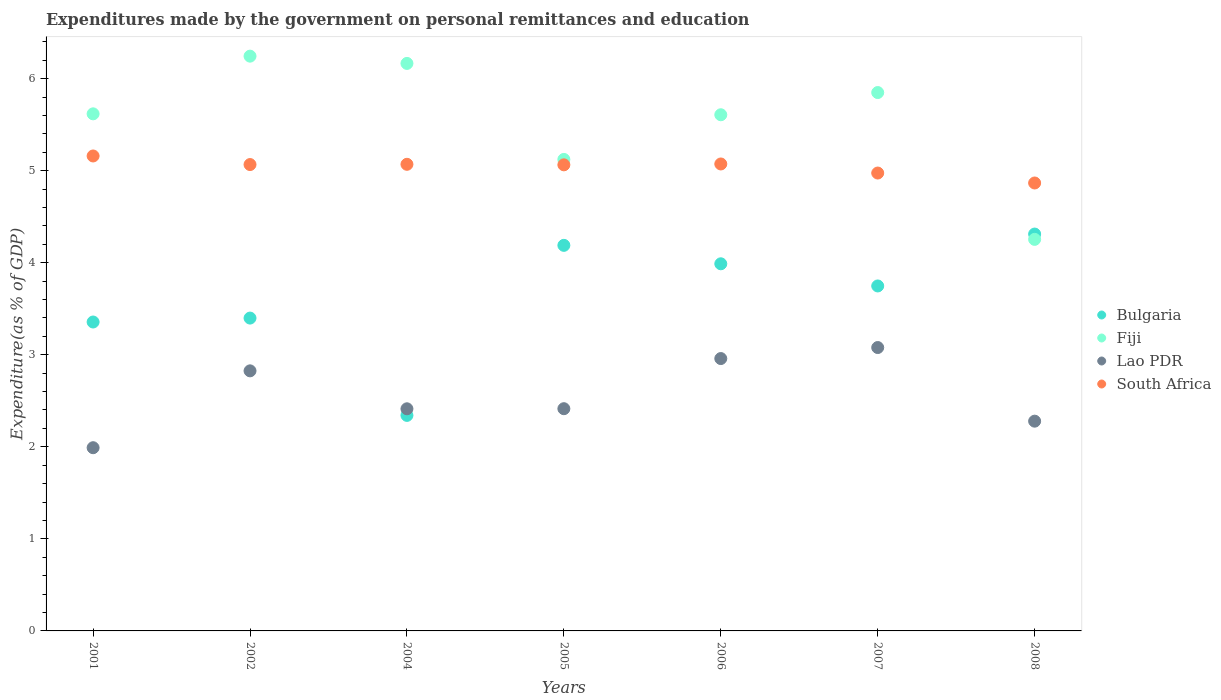Is the number of dotlines equal to the number of legend labels?
Your answer should be very brief. Yes. What is the expenditures made by the government on personal remittances and education in Fiji in 2006?
Provide a short and direct response. 5.61. Across all years, what is the maximum expenditures made by the government on personal remittances and education in Lao PDR?
Your response must be concise. 3.08. Across all years, what is the minimum expenditures made by the government on personal remittances and education in Lao PDR?
Your answer should be very brief. 1.99. In which year was the expenditures made by the government on personal remittances and education in Lao PDR minimum?
Offer a very short reply. 2001. What is the total expenditures made by the government on personal remittances and education in Fiji in the graph?
Offer a terse response. 38.86. What is the difference between the expenditures made by the government on personal remittances and education in Bulgaria in 2004 and that in 2006?
Your response must be concise. -1.65. What is the difference between the expenditures made by the government on personal remittances and education in Bulgaria in 2004 and the expenditures made by the government on personal remittances and education in Lao PDR in 2005?
Give a very brief answer. -0.07. What is the average expenditures made by the government on personal remittances and education in Bulgaria per year?
Give a very brief answer. 3.62. In the year 2007, what is the difference between the expenditures made by the government on personal remittances and education in Lao PDR and expenditures made by the government on personal remittances and education in South Africa?
Your response must be concise. -1.9. In how many years, is the expenditures made by the government on personal remittances and education in Lao PDR greater than 0.4 %?
Make the answer very short. 7. What is the ratio of the expenditures made by the government on personal remittances and education in Bulgaria in 2001 to that in 2006?
Ensure brevity in your answer.  0.84. Is the expenditures made by the government on personal remittances and education in Fiji in 2002 less than that in 2008?
Provide a succinct answer. No. What is the difference between the highest and the second highest expenditures made by the government on personal remittances and education in Bulgaria?
Your response must be concise. 0.12. What is the difference between the highest and the lowest expenditures made by the government on personal remittances and education in South Africa?
Provide a succinct answer. 0.29. In how many years, is the expenditures made by the government on personal remittances and education in Fiji greater than the average expenditures made by the government on personal remittances and education in Fiji taken over all years?
Keep it short and to the point. 5. Is it the case that in every year, the sum of the expenditures made by the government on personal remittances and education in Bulgaria and expenditures made by the government on personal remittances and education in Fiji  is greater than the expenditures made by the government on personal remittances and education in Lao PDR?
Ensure brevity in your answer.  Yes. Is the expenditures made by the government on personal remittances and education in Fiji strictly greater than the expenditures made by the government on personal remittances and education in Lao PDR over the years?
Your answer should be very brief. Yes. Is the expenditures made by the government on personal remittances and education in Bulgaria strictly less than the expenditures made by the government on personal remittances and education in South Africa over the years?
Ensure brevity in your answer.  Yes. How many dotlines are there?
Give a very brief answer. 4. How many years are there in the graph?
Keep it short and to the point. 7. Are the values on the major ticks of Y-axis written in scientific E-notation?
Give a very brief answer. No. Does the graph contain any zero values?
Make the answer very short. No. Where does the legend appear in the graph?
Your answer should be compact. Center right. How many legend labels are there?
Keep it short and to the point. 4. How are the legend labels stacked?
Your answer should be compact. Vertical. What is the title of the graph?
Give a very brief answer. Expenditures made by the government on personal remittances and education. Does "Benin" appear as one of the legend labels in the graph?
Give a very brief answer. No. What is the label or title of the X-axis?
Keep it short and to the point. Years. What is the label or title of the Y-axis?
Your answer should be very brief. Expenditure(as % of GDP). What is the Expenditure(as % of GDP) of Bulgaria in 2001?
Keep it short and to the point. 3.36. What is the Expenditure(as % of GDP) in Fiji in 2001?
Your answer should be very brief. 5.62. What is the Expenditure(as % of GDP) of Lao PDR in 2001?
Ensure brevity in your answer.  1.99. What is the Expenditure(as % of GDP) of South Africa in 2001?
Your response must be concise. 5.16. What is the Expenditure(as % of GDP) of Bulgaria in 2002?
Keep it short and to the point. 3.4. What is the Expenditure(as % of GDP) in Fiji in 2002?
Make the answer very short. 6.24. What is the Expenditure(as % of GDP) of Lao PDR in 2002?
Make the answer very short. 2.83. What is the Expenditure(as % of GDP) in South Africa in 2002?
Your answer should be very brief. 5.07. What is the Expenditure(as % of GDP) in Bulgaria in 2004?
Provide a short and direct response. 2.34. What is the Expenditure(as % of GDP) of Fiji in 2004?
Your answer should be very brief. 6.16. What is the Expenditure(as % of GDP) of Lao PDR in 2004?
Provide a succinct answer. 2.41. What is the Expenditure(as % of GDP) in South Africa in 2004?
Ensure brevity in your answer.  5.07. What is the Expenditure(as % of GDP) in Bulgaria in 2005?
Give a very brief answer. 4.19. What is the Expenditure(as % of GDP) in Fiji in 2005?
Your response must be concise. 5.12. What is the Expenditure(as % of GDP) in Lao PDR in 2005?
Your answer should be compact. 2.41. What is the Expenditure(as % of GDP) in South Africa in 2005?
Give a very brief answer. 5.06. What is the Expenditure(as % of GDP) in Bulgaria in 2006?
Make the answer very short. 3.99. What is the Expenditure(as % of GDP) in Fiji in 2006?
Your response must be concise. 5.61. What is the Expenditure(as % of GDP) in Lao PDR in 2006?
Provide a short and direct response. 2.96. What is the Expenditure(as % of GDP) of South Africa in 2006?
Your answer should be compact. 5.07. What is the Expenditure(as % of GDP) of Bulgaria in 2007?
Provide a short and direct response. 3.75. What is the Expenditure(as % of GDP) of Fiji in 2007?
Your answer should be compact. 5.85. What is the Expenditure(as % of GDP) of Lao PDR in 2007?
Keep it short and to the point. 3.08. What is the Expenditure(as % of GDP) in South Africa in 2007?
Your answer should be compact. 4.97. What is the Expenditure(as % of GDP) in Bulgaria in 2008?
Offer a terse response. 4.31. What is the Expenditure(as % of GDP) in Fiji in 2008?
Your answer should be very brief. 4.25. What is the Expenditure(as % of GDP) of Lao PDR in 2008?
Provide a succinct answer. 2.28. What is the Expenditure(as % of GDP) of South Africa in 2008?
Your answer should be very brief. 4.87. Across all years, what is the maximum Expenditure(as % of GDP) of Bulgaria?
Make the answer very short. 4.31. Across all years, what is the maximum Expenditure(as % of GDP) in Fiji?
Give a very brief answer. 6.24. Across all years, what is the maximum Expenditure(as % of GDP) in Lao PDR?
Offer a very short reply. 3.08. Across all years, what is the maximum Expenditure(as % of GDP) in South Africa?
Your response must be concise. 5.16. Across all years, what is the minimum Expenditure(as % of GDP) of Bulgaria?
Provide a succinct answer. 2.34. Across all years, what is the minimum Expenditure(as % of GDP) in Fiji?
Provide a short and direct response. 4.25. Across all years, what is the minimum Expenditure(as % of GDP) of Lao PDR?
Ensure brevity in your answer.  1.99. Across all years, what is the minimum Expenditure(as % of GDP) of South Africa?
Provide a succinct answer. 4.87. What is the total Expenditure(as % of GDP) of Bulgaria in the graph?
Make the answer very short. 25.33. What is the total Expenditure(as % of GDP) in Fiji in the graph?
Keep it short and to the point. 38.86. What is the total Expenditure(as % of GDP) of Lao PDR in the graph?
Give a very brief answer. 17.96. What is the total Expenditure(as % of GDP) in South Africa in the graph?
Your answer should be very brief. 35.27. What is the difference between the Expenditure(as % of GDP) of Bulgaria in 2001 and that in 2002?
Give a very brief answer. -0.04. What is the difference between the Expenditure(as % of GDP) in Fiji in 2001 and that in 2002?
Offer a terse response. -0.63. What is the difference between the Expenditure(as % of GDP) of Lao PDR in 2001 and that in 2002?
Offer a terse response. -0.83. What is the difference between the Expenditure(as % of GDP) of South Africa in 2001 and that in 2002?
Provide a succinct answer. 0.09. What is the difference between the Expenditure(as % of GDP) in Bulgaria in 2001 and that in 2004?
Make the answer very short. 1.01. What is the difference between the Expenditure(as % of GDP) in Fiji in 2001 and that in 2004?
Offer a very short reply. -0.55. What is the difference between the Expenditure(as % of GDP) in Lao PDR in 2001 and that in 2004?
Your answer should be very brief. -0.42. What is the difference between the Expenditure(as % of GDP) in South Africa in 2001 and that in 2004?
Give a very brief answer. 0.09. What is the difference between the Expenditure(as % of GDP) in Bulgaria in 2001 and that in 2005?
Give a very brief answer. -0.83. What is the difference between the Expenditure(as % of GDP) of Fiji in 2001 and that in 2005?
Ensure brevity in your answer.  0.5. What is the difference between the Expenditure(as % of GDP) of Lao PDR in 2001 and that in 2005?
Make the answer very short. -0.42. What is the difference between the Expenditure(as % of GDP) of South Africa in 2001 and that in 2005?
Your response must be concise. 0.1. What is the difference between the Expenditure(as % of GDP) of Bulgaria in 2001 and that in 2006?
Offer a very short reply. -0.63. What is the difference between the Expenditure(as % of GDP) in Lao PDR in 2001 and that in 2006?
Provide a short and direct response. -0.97. What is the difference between the Expenditure(as % of GDP) in South Africa in 2001 and that in 2006?
Offer a very short reply. 0.09. What is the difference between the Expenditure(as % of GDP) of Bulgaria in 2001 and that in 2007?
Make the answer very short. -0.39. What is the difference between the Expenditure(as % of GDP) in Fiji in 2001 and that in 2007?
Your answer should be compact. -0.23. What is the difference between the Expenditure(as % of GDP) in Lao PDR in 2001 and that in 2007?
Provide a succinct answer. -1.09. What is the difference between the Expenditure(as % of GDP) of South Africa in 2001 and that in 2007?
Make the answer very short. 0.19. What is the difference between the Expenditure(as % of GDP) in Bulgaria in 2001 and that in 2008?
Your answer should be very brief. -0.96. What is the difference between the Expenditure(as % of GDP) in Fiji in 2001 and that in 2008?
Offer a very short reply. 1.36. What is the difference between the Expenditure(as % of GDP) in Lao PDR in 2001 and that in 2008?
Offer a terse response. -0.29. What is the difference between the Expenditure(as % of GDP) in South Africa in 2001 and that in 2008?
Your answer should be compact. 0.29. What is the difference between the Expenditure(as % of GDP) in Bulgaria in 2002 and that in 2004?
Ensure brevity in your answer.  1.06. What is the difference between the Expenditure(as % of GDP) of Fiji in 2002 and that in 2004?
Give a very brief answer. 0.08. What is the difference between the Expenditure(as % of GDP) of Lao PDR in 2002 and that in 2004?
Your answer should be compact. 0.41. What is the difference between the Expenditure(as % of GDP) of South Africa in 2002 and that in 2004?
Your answer should be compact. -0. What is the difference between the Expenditure(as % of GDP) in Bulgaria in 2002 and that in 2005?
Offer a very short reply. -0.79. What is the difference between the Expenditure(as % of GDP) in Fiji in 2002 and that in 2005?
Give a very brief answer. 1.12. What is the difference between the Expenditure(as % of GDP) of Lao PDR in 2002 and that in 2005?
Keep it short and to the point. 0.41. What is the difference between the Expenditure(as % of GDP) in South Africa in 2002 and that in 2005?
Ensure brevity in your answer.  0. What is the difference between the Expenditure(as % of GDP) of Bulgaria in 2002 and that in 2006?
Make the answer very short. -0.59. What is the difference between the Expenditure(as % of GDP) of Fiji in 2002 and that in 2006?
Your answer should be very brief. 0.64. What is the difference between the Expenditure(as % of GDP) of Lao PDR in 2002 and that in 2006?
Ensure brevity in your answer.  -0.13. What is the difference between the Expenditure(as % of GDP) in South Africa in 2002 and that in 2006?
Give a very brief answer. -0.01. What is the difference between the Expenditure(as % of GDP) in Bulgaria in 2002 and that in 2007?
Your answer should be compact. -0.35. What is the difference between the Expenditure(as % of GDP) in Fiji in 2002 and that in 2007?
Ensure brevity in your answer.  0.4. What is the difference between the Expenditure(as % of GDP) in Lao PDR in 2002 and that in 2007?
Your response must be concise. -0.25. What is the difference between the Expenditure(as % of GDP) in South Africa in 2002 and that in 2007?
Provide a succinct answer. 0.09. What is the difference between the Expenditure(as % of GDP) of Bulgaria in 2002 and that in 2008?
Your answer should be compact. -0.91. What is the difference between the Expenditure(as % of GDP) in Fiji in 2002 and that in 2008?
Provide a succinct answer. 1.99. What is the difference between the Expenditure(as % of GDP) of Lao PDR in 2002 and that in 2008?
Provide a short and direct response. 0.55. What is the difference between the Expenditure(as % of GDP) of South Africa in 2002 and that in 2008?
Your answer should be compact. 0.2. What is the difference between the Expenditure(as % of GDP) in Bulgaria in 2004 and that in 2005?
Offer a very short reply. -1.85. What is the difference between the Expenditure(as % of GDP) in Fiji in 2004 and that in 2005?
Make the answer very short. 1.04. What is the difference between the Expenditure(as % of GDP) of Lao PDR in 2004 and that in 2005?
Offer a very short reply. -0. What is the difference between the Expenditure(as % of GDP) of South Africa in 2004 and that in 2005?
Your answer should be compact. 0.01. What is the difference between the Expenditure(as % of GDP) of Bulgaria in 2004 and that in 2006?
Ensure brevity in your answer.  -1.65. What is the difference between the Expenditure(as % of GDP) in Fiji in 2004 and that in 2006?
Keep it short and to the point. 0.56. What is the difference between the Expenditure(as % of GDP) in Lao PDR in 2004 and that in 2006?
Your response must be concise. -0.55. What is the difference between the Expenditure(as % of GDP) of South Africa in 2004 and that in 2006?
Ensure brevity in your answer.  -0. What is the difference between the Expenditure(as % of GDP) of Bulgaria in 2004 and that in 2007?
Provide a succinct answer. -1.41. What is the difference between the Expenditure(as % of GDP) in Fiji in 2004 and that in 2007?
Keep it short and to the point. 0.32. What is the difference between the Expenditure(as % of GDP) in Lao PDR in 2004 and that in 2007?
Provide a succinct answer. -0.67. What is the difference between the Expenditure(as % of GDP) of South Africa in 2004 and that in 2007?
Make the answer very short. 0.09. What is the difference between the Expenditure(as % of GDP) in Bulgaria in 2004 and that in 2008?
Provide a succinct answer. -1.97. What is the difference between the Expenditure(as % of GDP) in Fiji in 2004 and that in 2008?
Offer a terse response. 1.91. What is the difference between the Expenditure(as % of GDP) of Lao PDR in 2004 and that in 2008?
Make the answer very short. 0.13. What is the difference between the Expenditure(as % of GDP) of South Africa in 2004 and that in 2008?
Keep it short and to the point. 0.2. What is the difference between the Expenditure(as % of GDP) of Bulgaria in 2005 and that in 2006?
Provide a succinct answer. 0.2. What is the difference between the Expenditure(as % of GDP) in Fiji in 2005 and that in 2006?
Your answer should be compact. -0.49. What is the difference between the Expenditure(as % of GDP) of Lao PDR in 2005 and that in 2006?
Your answer should be very brief. -0.54. What is the difference between the Expenditure(as % of GDP) of South Africa in 2005 and that in 2006?
Offer a very short reply. -0.01. What is the difference between the Expenditure(as % of GDP) in Bulgaria in 2005 and that in 2007?
Keep it short and to the point. 0.44. What is the difference between the Expenditure(as % of GDP) of Fiji in 2005 and that in 2007?
Give a very brief answer. -0.73. What is the difference between the Expenditure(as % of GDP) in Lao PDR in 2005 and that in 2007?
Offer a terse response. -0.66. What is the difference between the Expenditure(as % of GDP) in South Africa in 2005 and that in 2007?
Your answer should be compact. 0.09. What is the difference between the Expenditure(as % of GDP) in Bulgaria in 2005 and that in 2008?
Give a very brief answer. -0.12. What is the difference between the Expenditure(as % of GDP) of Fiji in 2005 and that in 2008?
Give a very brief answer. 0.87. What is the difference between the Expenditure(as % of GDP) of Lao PDR in 2005 and that in 2008?
Your answer should be compact. 0.14. What is the difference between the Expenditure(as % of GDP) in South Africa in 2005 and that in 2008?
Your response must be concise. 0.2. What is the difference between the Expenditure(as % of GDP) of Bulgaria in 2006 and that in 2007?
Your answer should be compact. 0.24. What is the difference between the Expenditure(as % of GDP) of Fiji in 2006 and that in 2007?
Give a very brief answer. -0.24. What is the difference between the Expenditure(as % of GDP) of Lao PDR in 2006 and that in 2007?
Your answer should be compact. -0.12. What is the difference between the Expenditure(as % of GDP) in South Africa in 2006 and that in 2007?
Your answer should be compact. 0.1. What is the difference between the Expenditure(as % of GDP) in Bulgaria in 2006 and that in 2008?
Give a very brief answer. -0.32. What is the difference between the Expenditure(as % of GDP) of Fiji in 2006 and that in 2008?
Your answer should be compact. 1.35. What is the difference between the Expenditure(as % of GDP) of Lao PDR in 2006 and that in 2008?
Your answer should be compact. 0.68. What is the difference between the Expenditure(as % of GDP) in South Africa in 2006 and that in 2008?
Provide a succinct answer. 0.21. What is the difference between the Expenditure(as % of GDP) in Bulgaria in 2007 and that in 2008?
Your answer should be compact. -0.56. What is the difference between the Expenditure(as % of GDP) in Fiji in 2007 and that in 2008?
Your answer should be compact. 1.59. What is the difference between the Expenditure(as % of GDP) in Lao PDR in 2007 and that in 2008?
Your response must be concise. 0.8. What is the difference between the Expenditure(as % of GDP) in South Africa in 2007 and that in 2008?
Make the answer very short. 0.11. What is the difference between the Expenditure(as % of GDP) in Bulgaria in 2001 and the Expenditure(as % of GDP) in Fiji in 2002?
Provide a short and direct response. -2.89. What is the difference between the Expenditure(as % of GDP) in Bulgaria in 2001 and the Expenditure(as % of GDP) in Lao PDR in 2002?
Your answer should be very brief. 0.53. What is the difference between the Expenditure(as % of GDP) in Bulgaria in 2001 and the Expenditure(as % of GDP) in South Africa in 2002?
Give a very brief answer. -1.71. What is the difference between the Expenditure(as % of GDP) of Fiji in 2001 and the Expenditure(as % of GDP) of Lao PDR in 2002?
Make the answer very short. 2.79. What is the difference between the Expenditure(as % of GDP) in Fiji in 2001 and the Expenditure(as % of GDP) in South Africa in 2002?
Give a very brief answer. 0.55. What is the difference between the Expenditure(as % of GDP) of Lao PDR in 2001 and the Expenditure(as % of GDP) of South Africa in 2002?
Keep it short and to the point. -3.08. What is the difference between the Expenditure(as % of GDP) in Bulgaria in 2001 and the Expenditure(as % of GDP) in Fiji in 2004?
Offer a terse response. -2.81. What is the difference between the Expenditure(as % of GDP) of Bulgaria in 2001 and the Expenditure(as % of GDP) of Lao PDR in 2004?
Ensure brevity in your answer.  0.94. What is the difference between the Expenditure(as % of GDP) in Bulgaria in 2001 and the Expenditure(as % of GDP) in South Africa in 2004?
Ensure brevity in your answer.  -1.71. What is the difference between the Expenditure(as % of GDP) of Fiji in 2001 and the Expenditure(as % of GDP) of Lao PDR in 2004?
Your answer should be compact. 3.2. What is the difference between the Expenditure(as % of GDP) in Fiji in 2001 and the Expenditure(as % of GDP) in South Africa in 2004?
Your answer should be very brief. 0.55. What is the difference between the Expenditure(as % of GDP) in Lao PDR in 2001 and the Expenditure(as % of GDP) in South Africa in 2004?
Make the answer very short. -3.08. What is the difference between the Expenditure(as % of GDP) of Bulgaria in 2001 and the Expenditure(as % of GDP) of Fiji in 2005?
Give a very brief answer. -1.77. What is the difference between the Expenditure(as % of GDP) in Bulgaria in 2001 and the Expenditure(as % of GDP) in Lao PDR in 2005?
Ensure brevity in your answer.  0.94. What is the difference between the Expenditure(as % of GDP) in Bulgaria in 2001 and the Expenditure(as % of GDP) in South Africa in 2005?
Give a very brief answer. -1.71. What is the difference between the Expenditure(as % of GDP) in Fiji in 2001 and the Expenditure(as % of GDP) in Lao PDR in 2005?
Your answer should be compact. 3.2. What is the difference between the Expenditure(as % of GDP) in Fiji in 2001 and the Expenditure(as % of GDP) in South Africa in 2005?
Offer a terse response. 0.55. What is the difference between the Expenditure(as % of GDP) in Lao PDR in 2001 and the Expenditure(as % of GDP) in South Africa in 2005?
Make the answer very short. -3.07. What is the difference between the Expenditure(as % of GDP) in Bulgaria in 2001 and the Expenditure(as % of GDP) in Fiji in 2006?
Ensure brevity in your answer.  -2.25. What is the difference between the Expenditure(as % of GDP) of Bulgaria in 2001 and the Expenditure(as % of GDP) of Lao PDR in 2006?
Give a very brief answer. 0.4. What is the difference between the Expenditure(as % of GDP) in Bulgaria in 2001 and the Expenditure(as % of GDP) in South Africa in 2006?
Your response must be concise. -1.72. What is the difference between the Expenditure(as % of GDP) in Fiji in 2001 and the Expenditure(as % of GDP) in Lao PDR in 2006?
Your answer should be very brief. 2.66. What is the difference between the Expenditure(as % of GDP) in Fiji in 2001 and the Expenditure(as % of GDP) in South Africa in 2006?
Your answer should be very brief. 0.54. What is the difference between the Expenditure(as % of GDP) of Lao PDR in 2001 and the Expenditure(as % of GDP) of South Africa in 2006?
Keep it short and to the point. -3.08. What is the difference between the Expenditure(as % of GDP) in Bulgaria in 2001 and the Expenditure(as % of GDP) in Fiji in 2007?
Ensure brevity in your answer.  -2.49. What is the difference between the Expenditure(as % of GDP) of Bulgaria in 2001 and the Expenditure(as % of GDP) of Lao PDR in 2007?
Your answer should be compact. 0.28. What is the difference between the Expenditure(as % of GDP) in Bulgaria in 2001 and the Expenditure(as % of GDP) in South Africa in 2007?
Offer a terse response. -1.62. What is the difference between the Expenditure(as % of GDP) in Fiji in 2001 and the Expenditure(as % of GDP) in Lao PDR in 2007?
Make the answer very short. 2.54. What is the difference between the Expenditure(as % of GDP) of Fiji in 2001 and the Expenditure(as % of GDP) of South Africa in 2007?
Offer a terse response. 0.64. What is the difference between the Expenditure(as % of GDP) in Lao PDR in 2001 and the Expenditure(as % of GDP) in South Africa in 2007?
Make the answer very short. -2.98. What is the difference between the Expenditure(as % of GDP) in Bulgaria in 2001 and the Expenditure(as % of GDP) in Fiji in 2008?
Ensure brevity in your answer.  -0.9. What is the difference between the Expenditure(as % of GDP) in Bulgaria in 2001 and the Expenditure(as % of GDP) in Lao PDR in 2008?
Ensure brevity in your answer.  1.08. What is the difference between the Expenditure(as % of GDP) in Bulgaria in 2001 and the Expenditure(as % of GDP) in South Africa in 2008?
Provide a succinct answer. -1.51. What is the difference between the Expenditure(as % of GDP) of Fiji in 2001 and the Expenditure(as % of GDP) of Lao PDR in 2008?
Provide a short and direct response. 3.34. What is the difference between the Expenditure(as % of GDP) in Fiji in 2001 and the Expenditure(as % of GDP) in South Africa in 2008?
Your answer should be very brief. 0.75. What is the difference between the Expenditure(as % of GDP) in Lao PDR in 2001 and the Expenditure(as % of GDP) in South Africa in 2008?
Make the answer very short. -2.88. What is the difference between the Expenditure(as % of GDP) of Bulgaria in 2002 and the Expenditure(as % of GDP) of Fiji in 2004?
Make the answer very short. -2.77. What is the difference between the Expenditure(as % of GDP) in Bulgaria in 2002 and the Expenditure(as % of GDP) in Lao PDR in 2004?
Ensure brevity in your answer.  0.99. What is the difference between the Expenditure(as % of GDP) of Bulgaria in 2002 and the Expenditure(as % of GDP) of South Africa in 2004?
Keep it short and to the point. -1.67. What is the difference between the Expenditure(as % of GDP) of Fiji in 2002 and the Expenditure(as % of GDP) of Lao PDR in 2004?
Offer a terse response. 3.83. What is the difference between the Expenditure(as % of GDP) in Fiji in 2002 and the Expenditure(as % of GDP) in South Africa in 2004?
Offer a very short reply. 1.17. What is the difference between the Expenditure(as % of GDP) of Lao PDR in 2002 and the Expenditure(as % of GDP) of South Africa in 2004?
Give a very brief answer. -2.24. What is the difference between the Expenditure(as % of GDP) in Bulgaria in 2002 and the Expenditure(as % of GDP) in Fiji in 2005?
Your response must be concise. -1.72. What is the difference between the Expenditure(as % of GDP) of Bulgaria in 2002 and the Expenditure(as % of GDP) of Lao PDR in 2005?
Keep it short and to the point. 0.98. What is the difference between the Expenditure(as % of GDP) of Bulgaria in 2002 and the Expenditure(as % of GDP) of South Africa in 2005?
Keep it short and to the point. -1.66. What is the difference between the Expenditure(as % of GDP) in Fiji in 2002 and the Expenditure(as % of GDP) in Lao PDR in 2005?
Your response must be concise. 3.83. What is the difference between the Expenditure(as % of GDP) in Fiji in 2002 and the Expenditure(as % of GDP) in South Africa in 2005?
Offer a terse response. 1.18. What is the difference between the Expenditure(as % of GDP) of Lao PDR in 2002 and the Expenditure(as % of GDP) of South Africa in 2005?
Give a very brief answer. -2.24. What is the difference between the Expenditure(as % of GDP) in Bulgaria in 2002 and the Expenditure(as % of GDP) in Fiji in 2006?
Ensure brevity in your answer.  -2.21. What is the difference between the Expenditure(as % of GDP) in Bulgaria in 2002 and the Expenditure(as % of GDP) in Lao PDR in 2006?
Keep it short and to the point. 0.44. What is the difference between the Expenditure(as % of GDP) of Bulgaria in 2002 and the Expenditure(as % of GDP) of South Africa in 2006?
Keep it short and to the point. -1.67. What is the difference between the Expenditure(as % of GDP) of Fiji in 2002 and the Expenditure(as % of GDP) of Lao PDR in 2006?
Your answer should be compact. 3.29. What is the difference between the Expenditure(as % of GDP) in Fiji in 2002 and the Expenditure(as % of GDP) in South Africa in 2006?
Offer a very short reply. 1.17. What is the difference between the Expenditure(as % of GDP) in Lao PDR in 2002 and the Expenditure(as % of GDP) in South Africa in 2006?
Offer a very short reply. -2.25. What is the difference between the Expenditure(as % of GDP) of Bulgaria in 2002 and the Expenditure(as % of GDP) of Fiji in 2007?
Ensure brevity in your answer.  -2.45. What is the difference between the Expenditure(as % of GDP) in Bulgaria in 2002 and the Expenditure(as % of GDP) in Lao PDR in 2007?
Your response must be concise. 0.32. What is the difference between the Expenditure(as % of GDP) of Bulgaria in 2002 and the Expenditure(as % of GDP) of South Africa in 2007?
Your answer should be compact. -1.58. What is the difference between the Expenditure(as % of GDP) of Fiji in 2002 and the Expenditure(as % of GDP) of Lao PDR in 2007?
Your answer should be compact. 3.17. What is the difference between the Expenditure(as % of GDP) in Fiji in 2002 and the Expenditure(as % of GDP) in South Africa in 2007?
Provide a succinct answer. 1.27. What is the difference between the Expenditure(as % of GDP) in Lao PDR in 2002 and the Expenditure(as % of GDP) in South Africa in 2007?
Ensure brevity in your answer.  -2.15. What is the difference between the Expenditure(as % of GDP) of Bulgaria in 2002 and the Expenditure(as % of GDP) of Fiji in 2008?
Offer a terse response. -0.86. What is the difference between the Expenditure(as % of GDP) in Bulgaria in 2002 and the Expenditure(as % of GDP) in Lao PDR in 2008?
Offer a terse response. 1.12. What is the difference between the Expenditure(as % of GDP) in Bulgaria in 2002 and the Expenditure(as % of GDP) in South Africa in 2008?
Provide a short and direct response. -1.47. What is the difference between the Expenditure(as % of GDP) in Fiji in 2002 and the Expenditure(as % of GDP) in Lao PDR in 2008?
Ensure brevity in your answer.  3.97. What is the difference between the Expenditure(as % of GDP) of Fiji in 2002 and the Expenditure(as % of GDP) of South Africa in 2008?
Offer a very short reply. 1.38. What is the difference between the Expenditure(as % of GDP) of Lao PDR in 2002 and the Expenditure(as % of GDP) of South Africa in 2008?
Ensure brevity in your answer.  -2.04. What is the difference between the Expenditure(as % of GDP) in Bulgaria in 2004 and the Expenditure(as % of GDP) in Fiji in 2005?
Give a very brief answer. -2.78. What is the difference between the Expenditure(as % of GDP) in Bulgaria in 2004 and the Expenditure(as % of GDP) in Lao PDR in 2005?
Ensure brevity in your answer.  -0.07. What is the difference between the Expenditure(as % of GDP) in Bulgaria in 2004 and the Expenditure(as % of GDP) in South Africa in 2005?
Offer a very short reply. -2.72. What is the difference between the Expenditure(as % of GDP) of Fiji in 2004 and the Expenditure(as % of GDP) of Lao PDR in 2005?
Offer a very short reply. 3.75. What is the difference between the Expenditure(as % of GDP) of Fiji in 2004 and the Expenditure(as % of GDP) of South Africa in 2005?
Offer a terse response. 1.1. What is the difference between the Expenditure(as % of GDP) of Lao PDR in 2004 and the Expenditure(as % of GDP) of South Africa in 2005?
Provide a succinct answer. -2.65. What is the difference between the Expenditure(as % of GDP) of Bulgaria in 2004 and the Expenditure(as % of GDP) of Fiji in 2006?
Offer a very short reply. -3.27. What is the difference between the Expenditure(as % of GDP) of Bulgaria in 2004 and the Expenditure(as % of GDP) of Lao PDR in 2006?
Provide a succinct answer. -0.62. What is the difference between the Expenditure(as % of GDP) of Bulgaria in 2004 and the Expenditure(as % of GDP) of South Africa in 2006?
Your answer should be very brief. -2.73. What is the difference between the Expenditure(as % of GDP) of Fiji in 2004 and the Expenditure(as % of GDP) of Lao PDR in 2006?
Your answer should be very brief. 3.21. What is the difference between the Expenditure(as % of GDP) of Fiji in 2004 and the Expenditure(as % of GDP) of South Africa in 2006?
Your answer should be compact. 1.09. What is the difference between the Expenditure(as % of GDP) in Lao PDR in 2004 and the Expenditure(as % of GDP) in South Africa in 2006?
Give a very brief answer. -2.66. What is the difference between the Expenditure(as % of GDP) in Bulgaria in 2004 and the Expenditure(as % of GDP) in Fiji in 2007?
Offer a terse response. -3.51. What is the difference between the Expenditure(as % of GDP) in Bulgaria in 2004 and the Expenditure(as % of GDP) in Lao PDR in 2007?
Your answer should be compact. -0.74. What is the difference between the Expenditure(as % of GDP) of Bulgaria in 2004 and the Expenditure(as % of GDP) of South Africa in 2007?
Give a very brief answer. -2.63. What is the difference between the Expenditure(as % of GDP) of Fiji in 2004 and the Expenditure(as % of GDP) of Lao PDR in 2007?
Your answer should be compact. 3.09. What is the difference between the Expenditure(as % of GDP) of Fiji in 2004 and the Expenditure(as % of GDP) of South Africa in 2007?
Your response must be concise. 1.19. What is the difference between the Expenditure(as % of GDP) in Lao PDR in 2004 and the Expenditure(as % of GDP) in South Africa in 2007?
Your answer should be compact. -2.56. What is the difference between the Expenditure(as % of GDP) in Bulgaria in 2004 and the Expenditure(as % of GDP) in Fiji in 2008?
Offer a very short reply. -1.91. What is the difference between the Expenditure(as % of GDP) in Bulgaria in 2004 and the Expenditure(as % of GDP) in Lao PDR in 2008?
Give a very brief answer. 0.06. What is the difference between the Expenditure(as % of GDP) of Bulgaria in 2004 and the Expenditure(as % of GDP) of South Africa in 2008?
Provide a short and direct response. -2.52. What is the difference between the Expenditure(as % of GDP) of Fiji in 2004 and the Expenditure(as % of GDP) of Lao PDR in 2008?
Offer a terse response. 3.89. What is the difference between the Expenditure(as % of GDP) in Fiji in 2004 and the Expenditure(as % of GDP) in South Africa in 2008?
Give a very brief answer. 1.3. What is the difference between the Expenditure(as % of GDP) in Lao PDR in 2004 and the Expenditure(as % of GDP) in South Africa in 2008?
Offer a terse response. -2.45. What is the difference between the Expenditure(as % of GDP) in Bulgaria in 2005 and the Expenditure(as % of GDP) in Fiji in 2006?
Your response must be concise. -1.42. What is the difference between the Expenditure(as % of GDP) of Bulgaria in 2005 and the Expenditure(as % of GDP) of Lao PDR in 2006?
Offer a very short reply. 1.23. What is the difference between the Expenditure(as % of GDP) of Bulgaria in 2005 and the Expenditure(as % of GDP) of South Africa in 2006?
Your response must be concise. -0.88. What is the difference between the Expenditure(as % of GDP) in Fiji in 2005 and the Expenditure(as % of GDP) in Lao PDR in 2006?
Keep it short and to the point. 2.16. What is the difference between the Expenditure(as % of GDP) of Fiji in 2005 and the Expenditure(as % of GDP) of South Africa in 2006?
Your answer should be very brief. 0.05. What is the difference between the Expenditure(as % of GDP) of Lao PDR in 2005 and the Expenditure(as % of GDP) of South Africa in 2006?
Your answer should be very brief. -2.66. What is the difference between the Expenditure(as % of GDP) of Bulgaria in 2005 and the Expenditure(as % of GDP) of Fiji in 2007?
Your answer should be compact. -1.66. What is the difference between the Expenditure(as % of GDP) of Bulgaria in 2005 and the Expenditure(as % of GDP) of Lao PDR in 2007?
Give a very brief answer. 1.11. What is the difference between the Expenditure(as % of GDP) of Bulgaria in 2005 and the Expenditure(as % of GDP) of South Africa in 2007?
Provide a succinct answer. -0.79. What is the difference between the Expenditure(as % of GDP) of Fiji in 2005 and the Expenditure(as % of GDP) of Lao PDR in 2007?
Ensure brevity in your answer.  2.04. What is the difference between the Expenditure(as % of GDP) in Fiji in 2005 and the Expenditure(as % of GDP) in South Africa in 2007?
Your response must be concise. 0.15. What is the difference between the Expenditure(as % of GDP) of Lao PDR in 2005 and the Expenditure(as % of GDP) of South Africa in 2007?
Provide a short and direct response. -2.56. What is the difference between the Expenditure(as % of GDP) in Bulgaria in 2005 and the Expenditure(as % of GDP) in Fiji in 2008?
Your answer should be very brief. -0.07. What is the difference between the Expenditure(as % of GDP) of Bulgaria in 2005 and the Expenditure(as % of GDP) of Lao PDR in 2008?
Your response must be concise. 1.91. What is the difference between the Expenditure(as % of GDP) of Bulgaria in 2005 and the Expenditure(as % of GDP) of South Africa in 2008?
Your answer should be compact. -0.68. What is the difference between the Expenditure(as % of GDP) in Fiji in 2005 and the Expenditure(as % of GDP) in Lao PDR in 2008?
Keep it short and to the point. 2.84. What is the difference between the Expenditure(as % of GDP) of Fiji in 2005 and the Expenditure(as % of GDP) of South Africa in 2008?
Provide a short and direct response. 0.26. What is the difference between the Expenditure(as % of GDP) of Lao PDR in 2005 and the Expenditure(as % of GDP) of South Africa in 2008?
Your answer should be very brief. -2.45. What is the difference between the Expenditure(as % of GDP) in Bulgaria in 2006 and the Expenditure(as % of GDP) in Fiji in 2007?
Keep it short and to the point. -1.86. What is the difference between the Expenditure(as % of GDP) of Bulgaria in 2006 and the Expenditure(as % of GDP) of Lao PDR in 2007?
Give a very brief answer. 0.91. What is the difference between the Expenditure(as % of GDP) of Bulgaria in 2006 and the Expenditure(as % of GDP) of South Africa in 2007?
Provide a succinct answer. -0.99. What is the difference between the Expenditure(as % of GDP) in Fiji in 2006 and the Expenditure(as % of GDP) in Lao PDR in 2007?
Your answer should be compact. 2.53. What is the difference between the Expenditure(as % of GDP) in Fiji in 2006 and the Expenditure(as % of GDP) in South Africa in 2007?
Your response must be concise. 0.63. What is the difference between the Expenditure(as % of GDP) of Lao PDR in 2006 and the Expenditure(as % of GDP) of South Africa in 2007?
Ensure brevity in your answer.  -2.02. What is the difference between the Expenditure(as % of GDP) in Bulgaria in 2006 and the Expenditure(as % of GDP) in Fiji in 2008?
Ensure brevity in your answer.  -0.27. What is the difference between the Expenditure(as % of GDP) of Bulgaria in 2006 and the Expenditure(as % of GDP) of Lao PDR in 2008?
Offer a very short reply. 1.71. What is the difference between the Expenditure(as % of GDP) in Bulgaria in 2006 and the Expenditure(as % of GDP) in South Africa in 2008?
Give a very brief answer. -0.88. What is the difference between the Expenditure(as % of GDP) in Fiji in 2006 and the Expenditure(as % of GDP) in Lao PDR in 2008?
Keep it short and to the point. 3.33. What is the difference between the Expenditure(as % of GDP) in Fiji in 2006 and the Expenditure(as % of GDP) in South Africa in 2008?
Provide a short and direct response. 0.74. What is the difference between the Expenditure(as % of GDP) of Lao PDR in 2006 and the Expenditure(as % of GDP) of South Africa in 2008?
Provide a short and direct response. -1.91. What is the difference between the Expenditure(as % of GDP) in Bulgaria in 2007 and the Expenditure(as % of GDP) in Fiji in 2008?
Provide a succinct answer. -0.51. What is the difference between the Expenditure(as % of GDP) of Bulgaria in 2007 and the Expenditure(as % of GDP) of Lao PDR in 2008?
Offer a very short reply. 1.47. What is the difference between the Expenditure(as % of GDP) in Bulgaria in 2007 and the Expenditure(as % of GDP) in South Africa in 2008?
Your answer should be compact. -1.12. What is the difference between the Expenditure(as % of GDP) in Fiji in 2007 and the Expenditure(as % of GDP) in Lao PDR in 2008?
Keep it short and to the point. 3.57. What is the difference between the Expenditure(as % of GDP) in Fiji in 2007 and the Expenditure(as % of GDP) in South Africa in 2008?
Your response must be concise. 0.98. What is the difference between the Expenditure(as % of GDP) of Lao PDR in 2007 and the Expenditure(as % of GDP) of South Africa in 2008?
Give a very brief answer. -1.79. What is the average Expenditure(as % of GDP) in Bulgaria per year?
Offer a very short reply. 3.62. What is the average Expenditure(as % of GDP) in Fiji per year?
Give a very brief answer. 5.55. What is the average Expenditure(as % of GDP) of Lao PDR per year?
Offer a terse response. 2.57. What is the average Expenditure(as % of GDP) of South Africa per year?
Your answer should be very brief. 5.04. In the year 2001, what is the difference between the Expenditure(as % of GDP) of Bulgaria and Expenditure(as % of GDP) of Fiji?
Your answer should be compact. -2.26. In the year 2001, what is the difference between the Expenditure(as % of GDP) in Bulgaria and Expenditure(as % of GDP) in Lao PDR?
Your answer should be compact. 1.37. In the year 2001, what is the difference between the Expenditure(as % of GDP) of Bulgaria and Expenditure(as % of GDP) of South Africa?
Ensure brevity in your answer.  -1.8. In the year 2001, what is the difference between the Expenditure(as % of GDP) in Fiji and Expenditure(as % of GDP) in Lao PDR?
Offer a terse response. 3.63. In the year 2001, what is the difference between the Expenditure(as % of GDP) in Fiji and Expenditure(as % of GDP) in South Africa?
Give a very brief answer. 0.46. In the year 2001, what is the difference between the Expenditure(as % of GDP) in Lao PDR and Expenditure(as % of GDP) in South Africa?
Make the answer very short. -3.17. In the year 2002, what is the difference between the Expenditure(as % of GDP) of Bulgaria and Expenditure(as % of GDP) of Fiji?
Keep it short and to the point. -2.85. In the year 2002, what is the difference between the Expenditure(as % of GDP) in Bulgaria and Expenditure(as % of GDP) in Lao PDR?
Offer a very short reply. 0.57. In the year 2002, what is the difference between the Expenditure(as % of GDP) of Bulgaria and Expenditure(as % of GDP) of South Africa?
Your response must be concise. -1.67. In the year 2002, what is the difference between the Expenditure(as % of GDP) of Fiji and Expenditure(as % of GDP) of Lao PDR?
Provide a succinct answer. 3.42. In the year 2002, what is the difference between the Expenditure(as % of GDP) in Fiji and Expenditure(as % of GDP) in South Africa?
Your response must be concise. 1.18. In the year 2002, what is the difference between the Expenditure(as % of GDP) of Lao PDR and Expenditure(as % of GDP) of South Africa?
Provide a succinct answer. -2.24. In the year 2004, what is the difference between the Expenditure(as % of GDP) of Bulgaria and Expenditure(as % of GDP) of Fiji?
Keep it short and to the point. -3.82. In the year 2004, what is the difference between the Expenditure(as % of GDP) of Bulgaria and Expenditure(as % of GDP) of Lao PDR?
Offer a terse response. -0.07. In the year 2004, what is the difference between the Expenditure(as % of GDP) in Bulgaria and Expenditure(as % of GDP) in South Africa?
Your response must be concise. -2.73. In the year 2004, what is the difference between the Expenditure(as % of GDP) in Fiji and Expenditure(as % of GDP) in Lao PDR?
Your answer should be compact. 3.75. In the year 2004, what is the difference between the Expenditure(as % of GDP) in Fiji and Expenditure(as % of GDP) in South Africa?
Provide a short and direct response. 1.1. In the year 2004, what is the difference between the Expenditure(as % of GDP) in Lao PDR and Expenditure(as % of GDP) in South Africa?
Provide a succinct answer. -2.66. In the year 2005, what is the difference between the Expenditure(as % of GDP) in Bulgaria and Expenditure(as % of GDP) in Fiji?
Ensure brevity in your answer.  -0.93. In the year 2005, what is the difference between the Expenditure(as % of GDP) in Bulgaria and Expenditure(as % of GDP) in Lao PDR?
Your answer should be very brief. 1.77. In the year 2005, what is the difference between the Expenditure(as % of GDP) in Bulgaria and Expenditure(as % of GDP) in South Africa?
Ensure brevity in your answer.  -0.87. In the year 2005, what is the difference between the Expenditure(as % of GDP) in Fiji and Expenditure(as % of GDP) in Lao PDR?
Ensure brevity in your answer.  2.71. In the year 2005, what is the difference between the Expenditure(as % of GDP) of Fiji and Expenditure(as % of GDP) of South Africa?
Your answer should be very brief. 0.06. In the year 2005, what is the difference between the Expenditure(as % of GDP) in Lao PDR and Expenditure(as % of GDP) in South Africa?
Offer a very short reply. -2.65. In the year 2006, what is the difference between the Expenditure(as % of GDP) in Bulgaria and Expenditure(as % of GDP) in Fiji?
Give a very brief answer. -1.62. In the year 2006, what is the difference between the Expenditure(as % of GDP) in Bulgaria and Expenditure(as % of GDP) in Lao PDR?
Your answer should be very brief. 1.03. In the year 2006, what is the difference between the Expenditure(as % of GDP) in Bulgaria and Expenditure(as % of GDP) in South Africa?
Give a very brief answer. -1.08. In the year 2006, what is the difference between the Expenditure(as % of GDP) of Fiji and Expenditure(as % of GDP) of Lao PDR?
Keep it short and to the point. 2.65. In the year 2006, what is the difference between the Expenditure(as % of GDP) of Fiji and Expenditure(as % of GDP) of South Africa?
Offer a terse response. 0.53. In the year 2006, what is the difference between the Expenditure(as % of GDP) in Lao PDR and Expenditure(as % of GDP) in South Africa?
Provide a short and direct response. -2.11. In the year 2007, what is the difference between the Expenditure(as % of GDP) of Bulgaria and Expenditure(as % of GDP) of Fiji?
Provide a succinct answer. -2.1. In the year 2007, what is the difference between the Expenditure(as % of GDP) of Bulgaria and Expenditure(as % of GDP) of Lao PDR?
Make the answer very short. 0.67. In the year 2007, what is the difference between the Expenditure(as % of GDP) of Bulgaria and Expenditure(as % of GDP) of South Africa?
Provide a succinct answer. -1.23. In the year 2007, what is the difference between the Expenditure(as % of GDP) in Fiji and Expenditure(as % of GDP) in Lao PDR?
Provide a short and direct response. 2.77. In the year 2007, what is the difference between the Expenditure(as % of GDP) of Fiji and Expenditure(as % of GDP) of South Africa?
Your response must be concise. 0.87. In the year 2007, what is the difference between the Expenditure(as % of GDP) of Lao PDR and Expenditure(as % of GDP) of South Africa?
Ensure brevity in your answer.  -1.9. In the year 2008, what is the difference between the Expenditure(as % of GDP) in Bulgaria and Expenditure(as % of GDP) in Fiji?
Your response must be concise. 0.06. In the year 2008, what is the difference between the Expenditure(as % of GDP) of Bulgaria and Expenditure(as % of GDP) of Lao PDR?
Provide a short and direct response. 2.03. In the year 2008, what is the difference between the Expenditure(as % of GDP) of Bulgaria and Expenditure(as % of GDP) of South Africa?
Make the answer very short. -0.55. In the year 2008, what is the difference between the Expenditure(as % of GDP) in Fiji and Expenditure(as % of GDP) in Lao PDR?
Give a very brief answer. 1.98. In the year 2008, what is the difference between the Expenditure(as % of GDP) of Fiji and Expenditure(as % of GDP) of South Africa?
Your answer should be very brief. -0.61. In the year 2008, what is the difference between the Expenditure(as % of GDP) of Lao PDR and Expenditure(as % of GDP) of South Africa?
Offer a very short reply. -2.59. What is the ratio of the Expenditure(as % of GDP) of Bulgaria in 2001 to that in 2002?
Your answer should be very brief. 0.99. What is the ratio of the Expenditure(as % of GDP) of Fiji in 2001 to that in 2002?
Your response must be concise. 0.9. What is the ratio of the Expenditure(as % of GDP) of Lao PDR in 2001 to that in 2002?
Your response must be concise. 0.7. What is the ratio of the Expenditure(as % of GDP) in South Africa in 2001 to that in 2002?
Provide a short and direct response. 1.02. What is the ratio of the Expenditure(as % of GDP) of Bulgaria in 2001 to that in 2004?
Your answer should be very brief. 1.43. What is the ratio of the Expenditure(as % of GDP) in Fiji in 2001 to that in 2004?
Provide a succinct answer. 0.91. What is the ratio of the Expenditure(as % of GDP) in Lao PDR in 2001 to that in 2004?
Offer a very short reply. 0.82. What is the ratio of the Expenditure(as % of GDP) of South Africa in 2001 to that in 2004?
Keep it short and to the point. 1.02. What is the ratio of the Expenditure(as % of GDP) of Bulgaria in 2001 to that in 2005?
Offer a terse response. 0.8. What is the ratio of the Expenditure(as % of GDP) of Fiji in 2001 to that in 2005?
Offer a terse response. 1.1. What is the ratio of the Expenditure(as % of GDP) in Lao PDR in 2001 to that in 2005?
Give a very brief answer. 0.82. What is the ratio of the Expenditure(as % of GDP) of South Africa in 2001 to that in 2005?
Provide a succinct answer. 1.02. What is the ratio of the Expenditure(as % of GDP) in Bulgaria in 2001 to that in 2006?
Offer a terse response. 0.84. What is the ratio of the Expenditure(as % of GDP) in Lao PDR in 2001 to that in 2006?
Your response must be concise. 0.67. What is the ratio of the Expenditure(as % of GDP) in South Africa in 2001 to that in 2006?
Keep it short and to the point. 1.02. What is the ratio of the Expenditure(as % of GDP) of Bulgaria in 2001 to that in 2007?
Your answer should be compact. 0.9. What is the ratio of the Expenditure(as % of GDP) of Fiji in 2001 to that in 2007?
Your answer should be very brief. 0.96. What is the ratio of the Expenditure(as % of GDP) of Lao PDR in 2001 to that in 2007?
Your answer should be very brief. 0.65. What is the ratio of the Expenditure(as % of GDP) of South Africa in 2001 to that in 2007?
Provide a succinct answer. 1.04. What is the ratio of the Expenditure(as % of GDP) in Bulgaria in 2001 to that in 2008?
Give a very brief answer. 0.78. What is the ratio of the Expenditure(as % of GDP) of Fiji in 2001 to that in 2008?
Give a very brief answer. 1.32. What is the ratio of the Expenditure(as % of GDP) in Lao PDR in 2001 to that in 2008?
Your answer should be compact. 0.87. What is the ratio of the Expenditure(as % of GDP) of South Africa in 2001 to that in 2008?
Your answer should be very brief. 1.06. What is the ratio of the Expenditure(as % of GDP) of Bulgaria in 2002 to that in 2004?
Provide a succinct answer. 1.45. What is the ratio of the Expenditure(as % of GDP) of Fiji in 2002 to that in 2004?
Keep it short and to the point. 1.01. What is the ratio of the Expenditure(as % of GDP) of Lao PDR in 2002 to that in 2004?
Ensure brevity in your answer.  1.17. What is the ratio of the Expenditure(as % of GDP) of South Africa in 2002 to that in 2004?
Your answer should be compact. 1. What is the ratio of the Expenditure(as % of GDP) of Bulgaria in 2002 to that in 2005?
Offer a very short reply. 0.81. What is the ratio of the Expenditure(as % of GDP) in Fiji in 2002 to that in 2005?
Provide a short and direct response. 1.22. What is the ratio of the Expenditure(as % of GDP) of Lao PDR in 2002 to that in 2005?
Make the answer very short. 1.17. What is the ratio of the Expenditure(as % of GDP) in South Africa in 2002 to that in 2005?
Provide a succinct answer. 1. What is the ratio of the Expenditure(as % of GDP) in Bulgaria in 2002 to that in 2006?
Offer a terse response. 0.85. What is the ratio of the Expenditure(as % of GDP) of Fiji in 2002 to that in 2006?
Provide a succinct answer. 1.11. What is the ratio of the Expenditure(as % of GDP) of Lao PDR in 2002 to that in 2006?
Make the answer very short. 0.95. What is the ratio of the Expenditure(as % of GDP) of Bulgaria in 2002 to that in 2007?
Provide a short and direct response. 0.91. What is the ratio of the Expenditure(as % of GDP) of Fiji in 2002 to that in 2007?
Keep it short and to the point. 1.07. What is the ratio of the Expenditure(as % of GDP) of Lao PDR in 2002 to that in 2007?
Ensure brevity in your answer.  0.92. What is the ratio of the Expenditure(as % of GDP) in South Africa in 2002 to that in 2007?
Offer a terse response. 1.02. What is the ratio of the Expenditure(as % of GDP) of Bulgaria in 2002 to that in 2008?
Your answer should be very brief. 0.79. What is the ratio of the Expenditure(as % of GDP) of Fiji in 2002 to that in 2008?
Your response must be concise. 1.47. What is the ratio of the Expenditure(as % of GDP) in Lao PDR in 2002 to that in 2008?
Provide a succinct answer. 1.24. What is the ratio of the Expenditure(as % of GDP) of South Africa in 2002 to that in 2008?
Keep it short and to the point. 1.04. What is the ratio of the Expenditure(as % of GDP) of Bulgaria in 2004 to that in 2005?
Provide a short and direct response. 0.56. What is the ratio of the Expenditure(as % of GDP) in Fiji in 2004 to that in 2005?
Your answer should be very brief. 1.2. What is the ratio of the Expenditure(as % of GDP) of Bulgaria in 2004 to that in 2006?
Keep it short and to the point. 0.59. What is the ratio of the Expenditure(as % of GDP) of Fiji in 2004 to that in 2006?
Your answer should be very brief. 1.1. What is the ratio of the Expenditure(as % of GDP) in Lao PDR in 2004 to that in 2006?
Offer a very short reply. 0.82. What is the ratio of the Expenditure(as % of GDP) in Bulgaria in 2004 to that in 2007?
Make the answer very short. 0.62. What is the ratio of the Expenditure(as % of GDP) of Fiji in 2004 to that in 2007?
Keep it short and to the point. 1.05. What is the ratio of the Expenditure(as % of GDP) of Lao PDR in 2004 to that in 2007?
Offer a terse response. 0.78. What is the ratio of the Expenditure(as % of GDP) in South Africa in 2004 to that in 2007?
Provide a short and direct response. 1.02. What is the ratio of the Expenditure(as % of GDP) of Bulgaria in 2004 to that in 2008?
Give a very brief answer. 0.54. What is the ratio of the Expenditure(as % of GDP) in Fiji in 2004 to that in 2008?
Give a very brief answer. 1.45. What is the ratio of the Expenditure(as % of GDP) in Lao PDR in 2004 to that in 2008?
Give a very brief answer. 1.06. What is the ratio of the Expenditure(as % of GDP) in South Africa in 2004 to that in 2008?
Ensure brevity in your answer.  1.04. What is the ratio of the Expenditure(as % of GDP) of Bulgaria in 2005 to that in 2006?
Provide a short and direct response. 1.05. What is the ratio of the Expenditure(as % of GDP) of Fiji in 2005 to that in 2006?
Your answer should be compact. 0.91. What is the ratio of the Expenditure(as % of GDP) of Lao PDR in 2005 to that in 2006?
Your response must be concise. 0.82. What is the ratio of the Expenditure(as % of GDP) in Bulgaria in 2005 to that in 2007?
Offer a very short reply. 1.12. What is the ratio of the Expenditure(as % of GDP) in Fiji in 2005 to that in 2007?
Provide a succinct answer. 0.88. What is the ratio of the Expenditure(as % of GDP) of Lao PDR in 2005 to that in 2007?
Your response must be concise. 0.78. What is the ratio of the Expenditure(as % of GDP) in South Africa in 2005 to that in 2007?
Your response must be concise. 1.02. What is the ratio of the Expenditure(as % of GDP) in Bulgaria in 2005 to that in 2008?
Your response must be concise. 0.97. What is the ratio of the Expenditure(as % of GDP) of Fiji in 2005 to that in 2008?
Your answer should be compact. 1.2. What is the ratio of the Expenditure(as % of GDP) of Lao PDR in 2005 to that in 2008?
Your answer should be compact. 1.06. What is the ratio of the Expenditure(as % of GDP) of South Africa in 2005 to that in 2008?
Your response must be concise. 1.04. What is the ratio of the Expenditure(as % of GDP) of Bulgaria in 2006 to that in 2007?
Provide a short and direct response. 1.06. What is the ratio of the Expenditure(as % of GDP) in Fiji in 2006 to that in 2007?
Keep it short and to the point. 0.96. What is the ratio of the Expenditure(as % of GDP) of Lao PDR in 2006 to that in 2007?
Make the answer very short. 0.96. What is the ratio of the Expenditure(as % of GDP) of South Africa in 2006 to that in 2007?
Give a very brief answer. 1.02. What is the ratio of the Expenditure(as % of GDP) of Bulgaria in 2006 to that in 2008?
Make the answer very short. 0.93. What is the ratio of the Expenditure(as % of GDP) of Fiji in 2006 to that in 2008?
Offer a terse response. 1.32. What is the ratio of the Expenditure(as % of GDP) of Lao PDR in 2006 to that in 2008?
Provide a short and direct response. 1.3. What is the ratio of the Expenditure(as % of GDP) of South Africa in 2006 to that in 2008?
Offer a very short reply. 1.04. What is the ratio of the Expenditure(as % of GDP) of Bulgaria in 2007 to that in 2008?
Your answer should be compact. 0.87. What is the ratio of the Expenditure(as % of GDP) in Fiji in 2007 to that in 2008?
Your response must be concise. 1.37. What is the ratio of the Expenditure(as % of GDP) in Lao PDR in 2007 to that in 2008?
Give a very brief answer. 1.35. What is the ratio of the Expenditure(as % of GDP) of South Africa in 2007 to that in 2008?
Ensure brevity in your answer.  1.02. What is the difference between the highest and the second highest Expenditure(as % of GDP) of Bulgaria?
Keep it short and to the point. 0.12. What is the difference between the highest and the second highest Expenditure(as % of GDP) of Fiji?
Your answer should be compact. 0.08. What is the difference between the highest and the second highest Expenditure(as % of GDP) of Lao PDR?
Your answer should be compact. 0.12. What is the difference between the highest and the second highest Expenditure(as % of GDP) of South Africa?
Provide a succinct answer. 0.09. What is the difference between the highest and the lowest Expenditure(as % of GDP) in Bulgaria?
Your answer should be compact. 1.97. What is the difference between the highest and the lowest Expenditure(as % of GDP) of Fiji?
Your answer should be compact. 1.99. What is the difference between the highest and the lowest Expenditure(as % of GDP) of Lao PDR?
Your answer should be very brief. 1.09. What is the difference between the highest and the lowest Expenditure(as % of GDP) in South Africa?
Offer a very short reply. 0.29. 